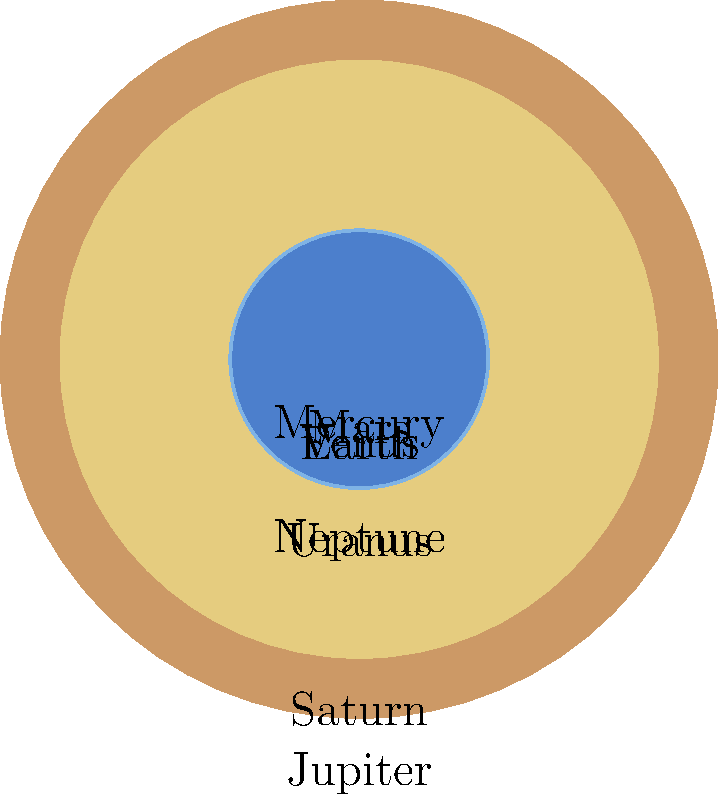As you observe the circular representations of planets in our solar system, which would be the most suitable analogy to describe the relationship between Jupiter and Earth, considering their relative sizes and the concept of balance in yoga practice? Let's approach this step-by-step, connecting astronomy with mindfulness and yoga concepts:

1. First, observe the relative sizes of the planets in the image. Jupiter is clearly the largest, while Earth is much smaller.

2. In the diagram, Jupiter's diameter is approximately 139,820 km, while Earth's is 12,742 km.

3. To calculate the ratio, we divide Jupiter's diameter by Earth's:
   $$\frac{139,820}{12,742} \approx 10.97$$

4. This means Jupiter is about 11 times wider than Earth.

5. In yoga practice, balance is crucial. We often use props or supports to help maintain balance in challenging poses.

6. The significant size difference between Jupiter and Earth can be likened to the balance required in a yoga pose where a small support (Earth) helps maintain the stability of a much larger body part (Jupiter).

7. In mindfulness practice, we often focus on how small changes can have big impacts, similar to how Earth, despite its smaller size, plays a crucial role in our solar system.

8. A suitable analogy in yoga terms would be comparing Jupiter to the body of a person in a balancing pose, while Earth represents the small but crucial point of contact with the ground that supports the entire posture.
Answer: Jupiter is like a yogi's body in a balancing pose, with Earth representing the small but essential point of contact supporting the entire posture. 